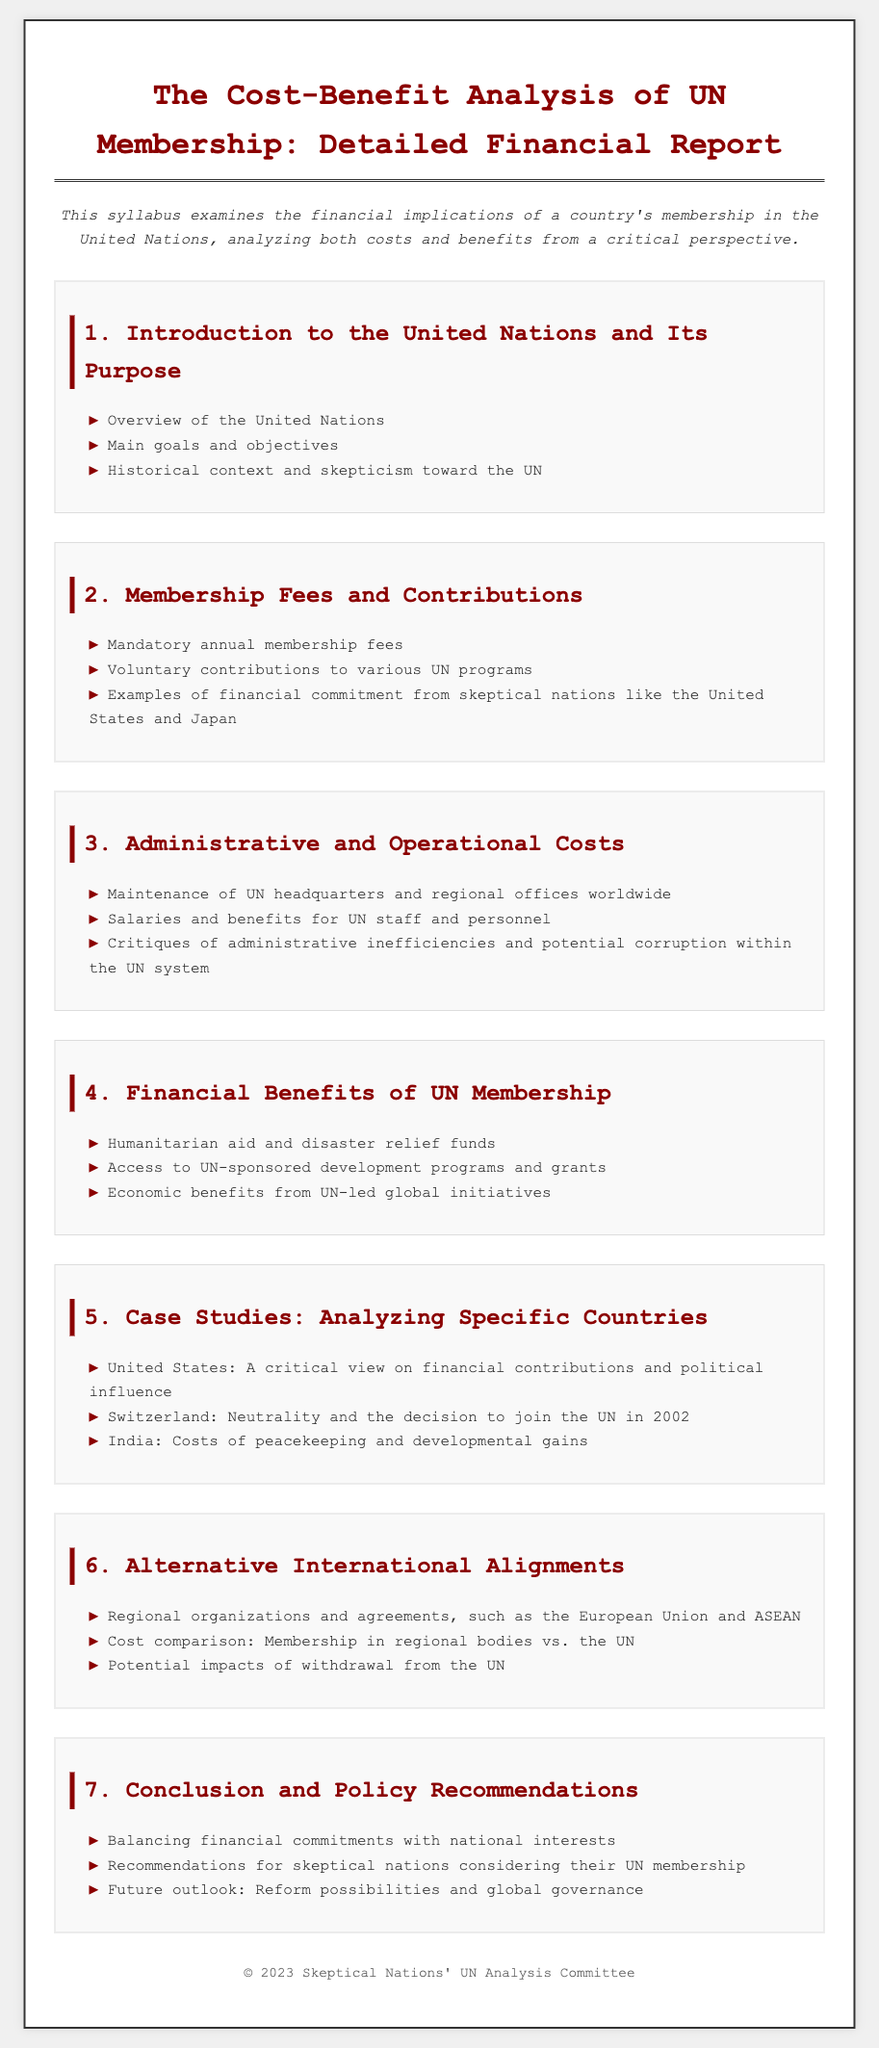What are the main goals of the UN? The main goals of the UN are outlined in the syllabus under "Main goals and objectives" in section 1.
Answer: Main goals and objectives What are mandatory membership fees? Mandatory membership fees are discussed in section 2, highlighting the financial commitments countries must uphold.
Answer: Mandatory annual membership fees Which country is used as a case study for financial contributions and political influence? The syllabus presents the United States as a critical case study in section 5.
Answer: United States What is one critique mentioned regarding UN administrative costs? The document refers to critiques concerning inefficiencies and corruption in the UN system in section 3.
Answer: Administrative inefficiencies What types of funds are mentioned as financial benefits of UN membership? The syllabus includes humanitarian aid and disaster relief funds as a benefit in section 4.
Answer: Humanitarian aid and disaster relief funds What is the title of section 6? The title of section 6 discusses alternative alignments to UN membership.
Answer: Alternative International Alignments What does section 7 focus on? Section 7 centers on recommendations and future outlook regarding UN membership for skeptical nations.
Answer: Conclusion and Policy Recommendations 